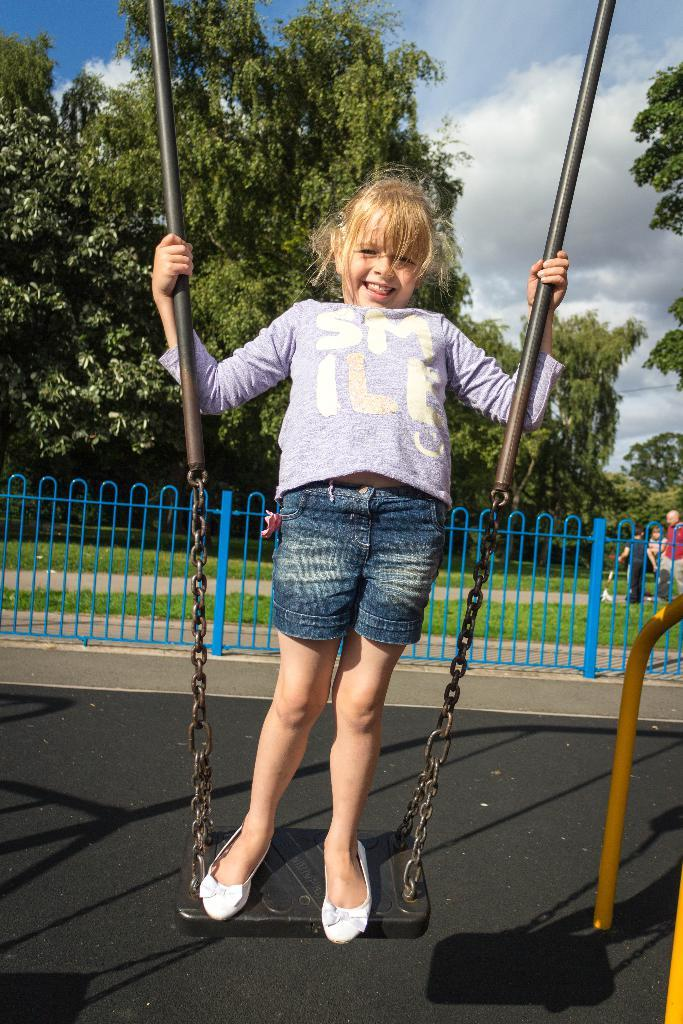Who is in the image? There is a girl in the image. What is the girl doing in the image? The girl is on a metal single swing. What is the girl's expression in the image? The girl is smiling. What can be seen in the background of the image? There is a metal fence and trees in the background of the image. What is visible in the sky in the image? There are clouds in the sky. What time of day is it in the image, and who is driving the car? There is no car or indication of time of day in the image; it features a girl on a swing with a background of trees and a metal fence. 